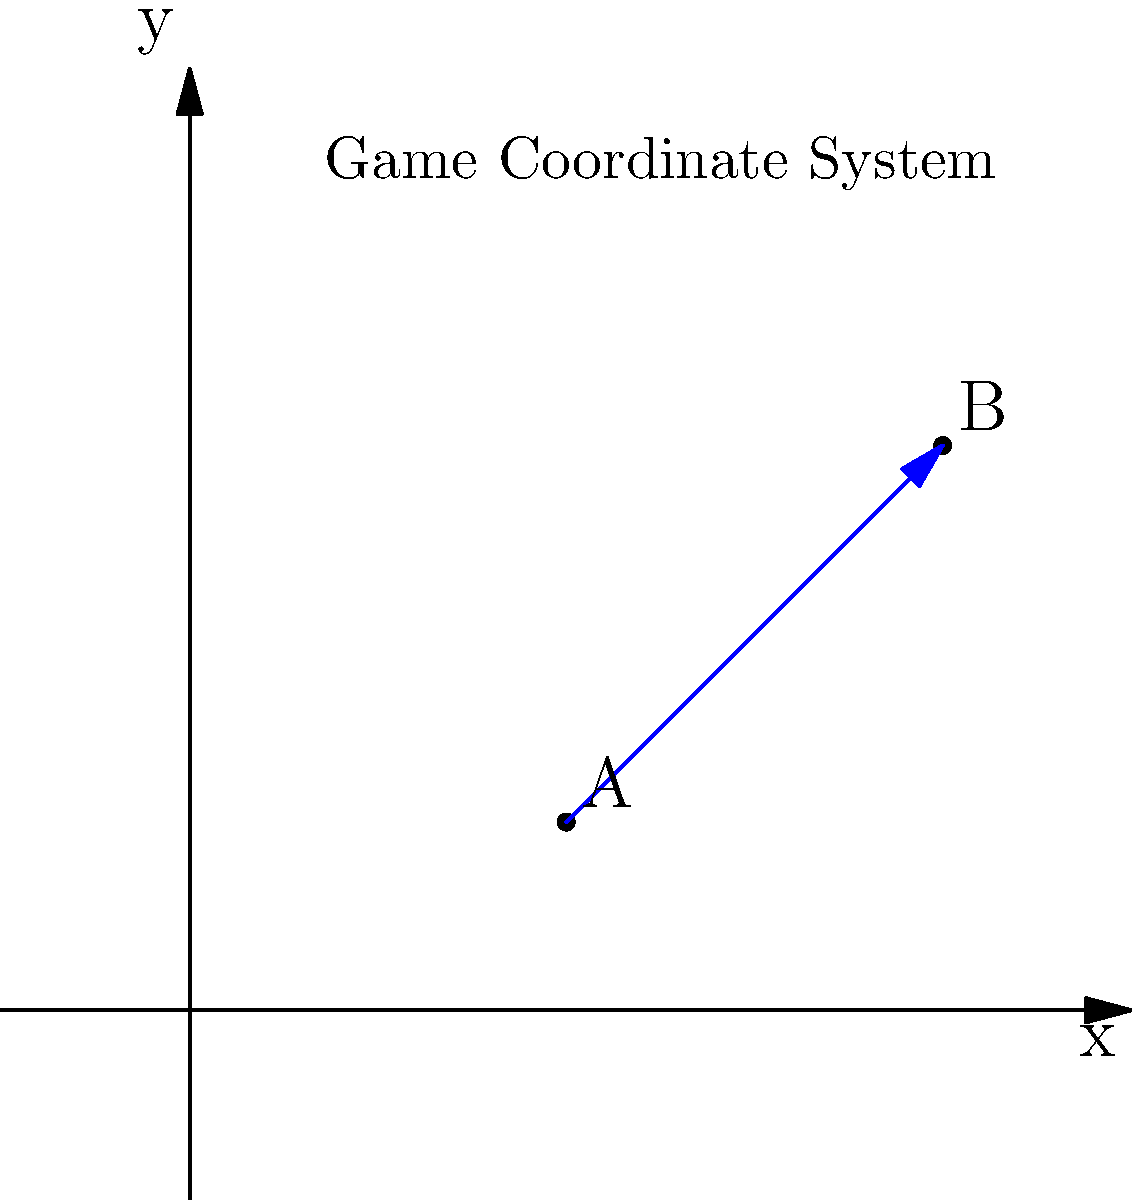In a 2D game, you need to convert the position of an object from one coordinate system to another. The object is at point A(2,1) in the current system, and you want to move it to point B(4,3). What is the translation vector needed to move the object from A to B? To find the translation vector, we need to follow these steps:

1. Identify the starting point A(2,1) and the ending point B(4,3).

2. Calculate the difference between the x-coordinates:
   $\Delta x = x_B - x_A = 4 - 2 = 2$

3. Calculate the difference between the y-coordinates:
   $\Delta y = y_B - y_A = 3 - 1 = 2$

4. The translation vector is represented by these differences:
   $\vec{v} = (\Delta x, \Delta y) = (2, 2)$

This vector $(2, 2)$ represents the displacement needed to move the object from point A to point B in the game's coordinate system.
Answer: $(2, 2)$ 